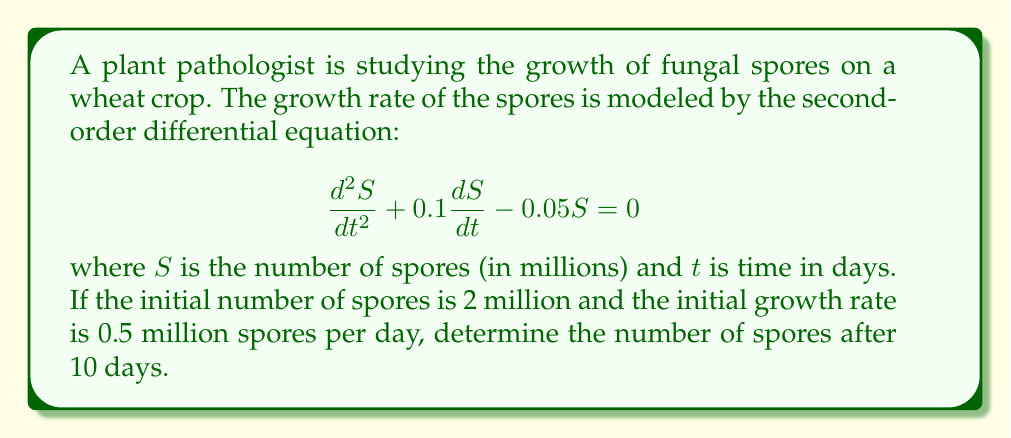Can you solve this math problem? To solve this problem, we need to follow these steps:

1) First, we need to find the general solution of the differential equation. The characteristic equation is:

   $$r^2 + 0.1r - 0.05 = 0$$

2) Solving this quadratic equation:
   
   $$r = \frac{-0.1 \pm \sqrt{0.1^2 + 4(0.05)}}{2} = \frac{-0.1 \pm \sqrt{0.21}}{2}$$

   $$r_1 = \frac{-0.1 + \sqrt{0.21}}{2} \approx 0.1791$$
   $$r_2 = \frac{-0.1 - \sqrt{0.21}}{2} \approx -0.2791$$

3) The general solution is:

   $$S(t) = C_1e^{0.1791t} + C_2e^{-0.2791t}$$

4) Now we use the initial conditions to find $C_1$ and $C_2$:
   
   At $t=0$, $S(0) = 2$, so:
   $$2 = C_1 + C_2$$

   The initial growth rate is 0.5, so $S'(0) = 0.5$:
   $$0.5 = 0.1791C_1 - 0.2791C_2$$

5) Solving these simultaneous equations:

   $$C_1 \approx 2.5486$$
   $$C_2 \approx -0.5486$$

6) Therefore, the particular solution is:

   $$S(t) = 2.5486e^{0.1791t} - 0.5486e^{-0.2791t}$$

7) To find the number of spores after 10 days, we substitute $t=10$:

   $$S(10) = 2.5486e^{0.1791(10)} - 0.5486e^{-0.2791(10)}$$
Answer: $$S(10) \approx 7.9441$$ million spores 